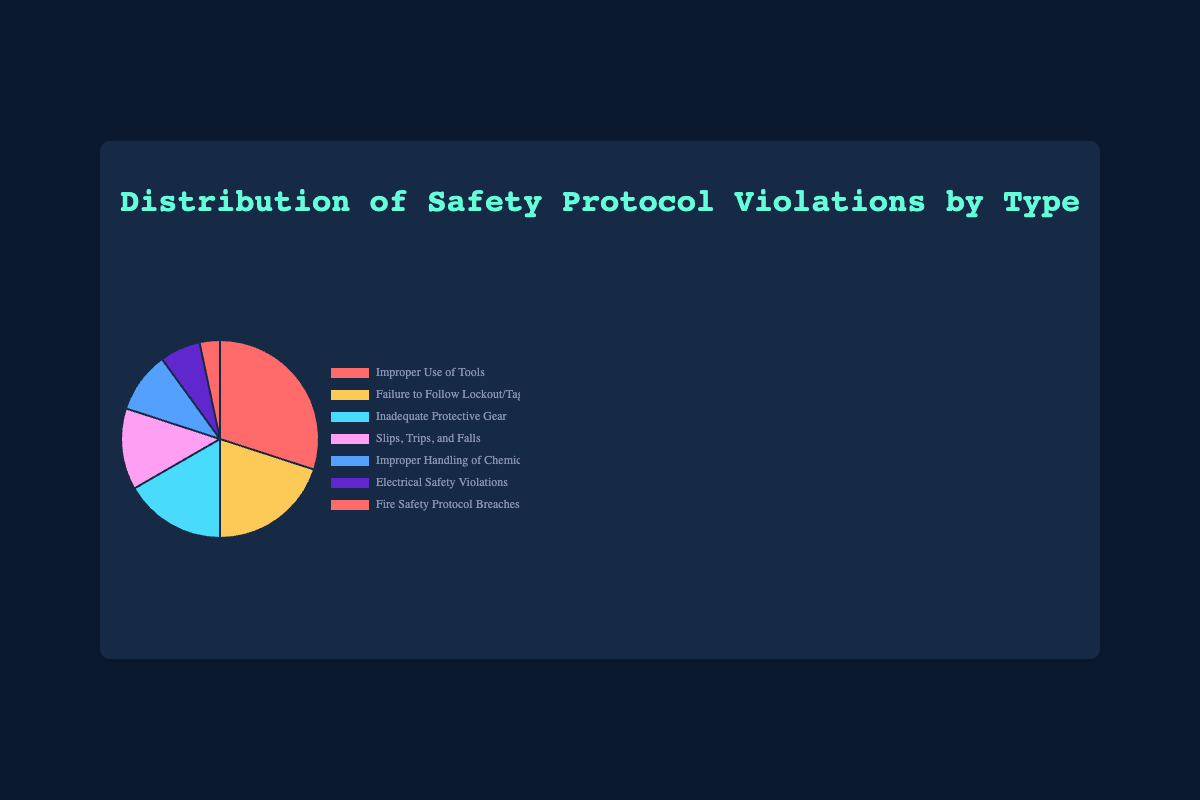Which type of safety protocol violation has the highest number of incidents? The type with the highest number of incidents can be identified by looking at the largest segment of the pie chart. In this case, "Improper Use of Tools" has 45 incidents, which is the largest segment.
Answer: Improper Use of Tools What percentage of total incidents is due to "Failure to Follow Lockout/Tagout Procedures"? First, calculate the total number of incidents by summing all the values: 45 + 30 + 25 + 20 + 15 + 10 + 5 = 150. Then, find the percentage: (30 / 150) * 100 = 20%.
Answer: 20% Which safety protocol violation type has the smallest number of incidents? The type with the smallest number of incidents can be identified by looking at the smallest segment of the pie chart. "Fire Safety Protocol Breaches" has 5 incidents, which is the smallest segment.
Answer: Fire Safety Protocol Breaches How many more incidents are "Improper Use of Tools" compared to "Electrical Safety Violations"? "Improper Use of Tools" has 45 incidents and "Electrical Safety Violations" has 10 incidents. Subtracting these gives: 45 - 10 = 35.
Answer: 35 What is the combined percentage of incidents from "Slips, Trips, and Falls" and "Improper Handling of Chemicals"? First, calculate the total number of incidents: 45 + 30 + 25 + 20 + 15 + 10 + 5 = 150. Then, sum the incidents for the two types: 20 + 15 = 35. Finally, find the percentage: (35 / 150) * 100 = 23.33%.
Answer: 23.33% If "Inadequate Protective Gear" incidents were reduced by 5, what would the new total number of incidents be? The current total number of incidents is 150. Reducing "Inadequate Protective Gear" incidents by 5 gives: 25 - 5 = 20. The new total is: 150 - 5 = 145.
Answer: 145 Which violation is visually represented by a blue segment in the pie chart? From the defined colors, "Improper Handling of Chemicals" is represented by the blue segment.
Answer: Improper Handling of Chemicals Is the total number of incidents for "Inadequate Protective Gear" greater than "Fire Safety Protocol Breaches" and "Electrical Safety Violations" combined? "Inadequate Protective Gear" has 25 incidents. Combined, "Fire Safety Protocol Breaches" and "Electrical Safety Violations" have: 5 + 10 = 15. Since 25 > 15, the total for "Inadequate Protective Gear" is indeed greater.
Answer: Yes What fraction of the total incidents is constituted by "Slips, Trips, and Falls"? The total number of incidents is 150. The incidents from "Slips, Trips, and Falls" are 20. The fraction is thus 20/150, which simplifies to 2/15.
Answer: 2/15 